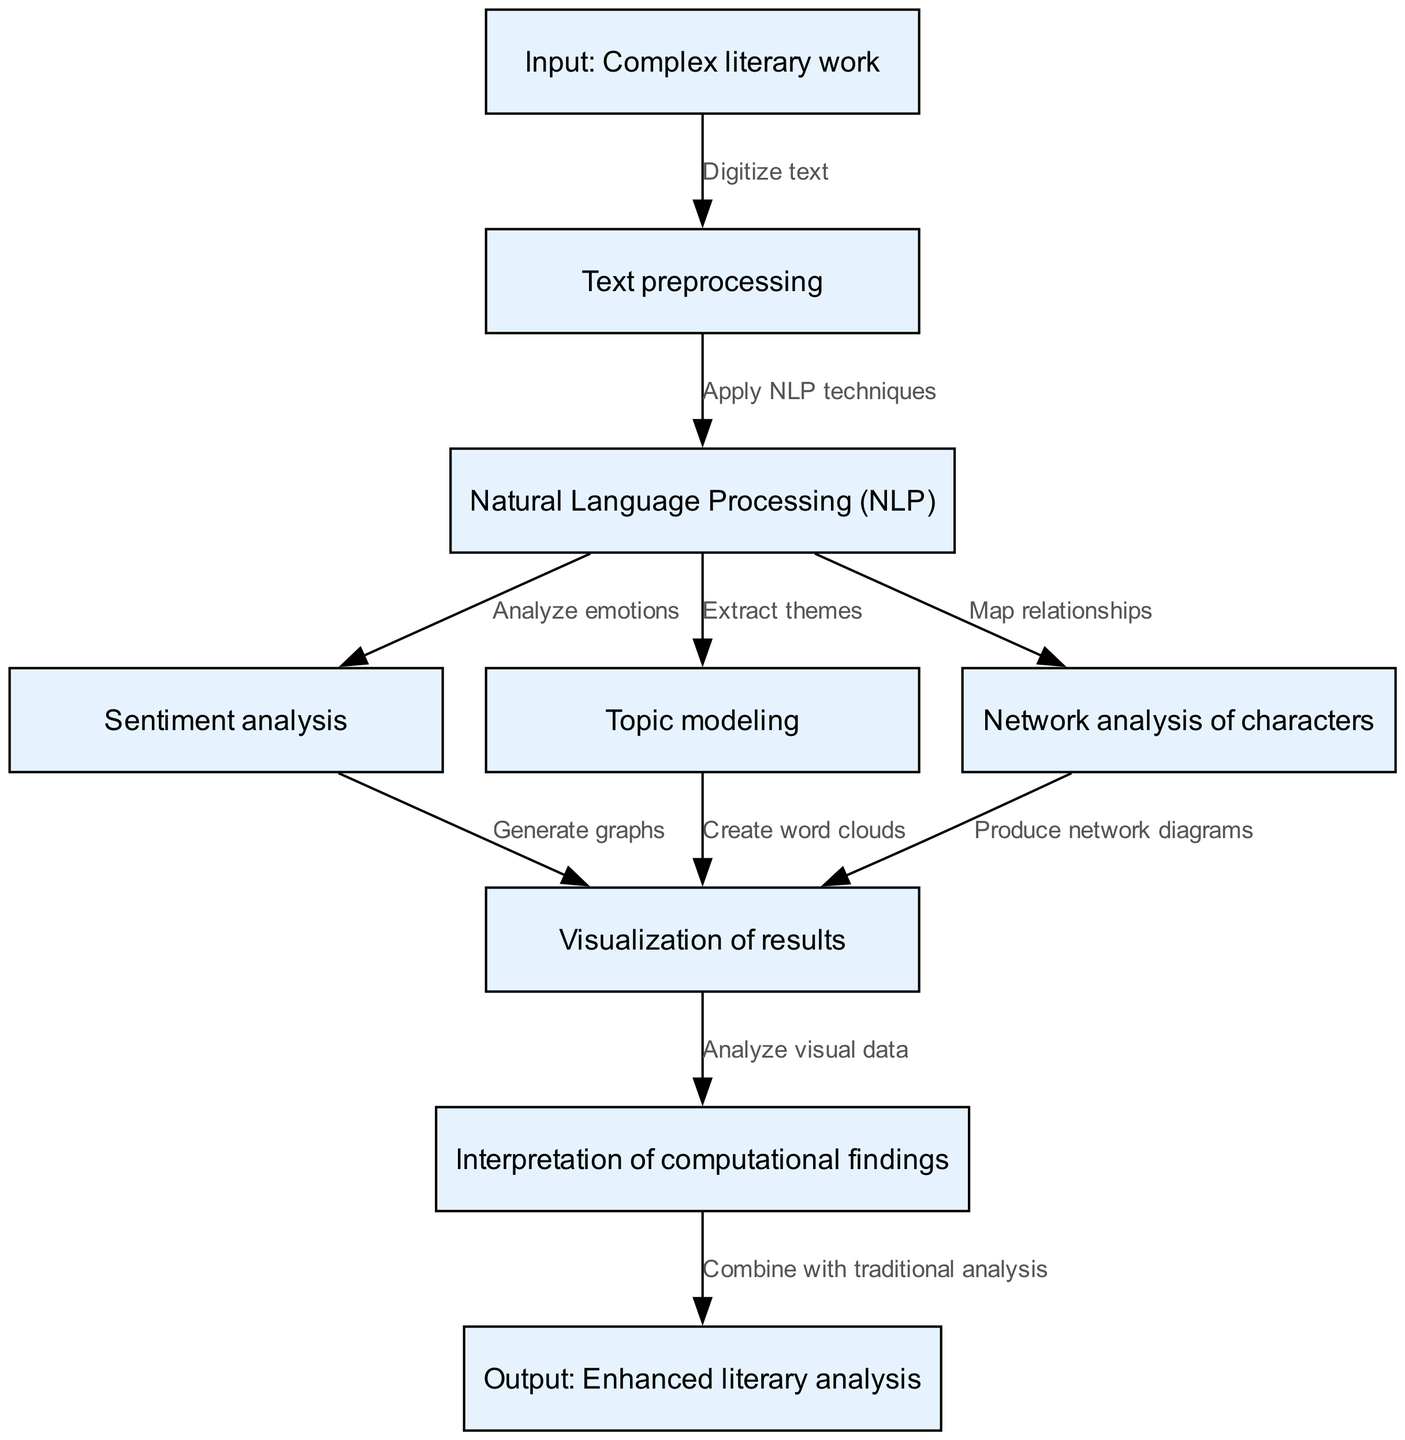What is the starting input for the analysis? The starting input node in the diagram is labeled "Input: Complex literary work," indicating that this is where the process begins.
Answer: Complex literary work How many nodes are present in the diagram? By counting all the items within the "nodes" array, there are a total of nine nodes depicted in the flow chart.
Answer: 9 What node follows "Text preprocessing"? Following the "Text preprocessing" node, the diagram indicates the next step is "Natural Language Processing (NLP)," which is the immediate consequence of preprocessing.
Answer: Natural Language Processing (NLP) Which analysis type focuses on emotions? The node dedicated to analyzing emotions is labeled "Sentiment analysis," signifying that this part of the process specifically addresses emotional content in the text.
Answer: Sentiment analysis What is produced from "Network analysis of characters"? The output related to "Network analysis of characters" leads to the node "Produce network diagrams," indicating that this is the result of analyzing character relationships.
Answer: Produce network diagrams How is "Visualization of results" achieved? The visualization of results is accomplished through three processes: "Generate graphs" from sentiment analysis, "Create word clouds" from topic modeling, and "Produce network diagrams" from character analysis, all combining to create visual outputs.
Answer: Generate graphs, Create word clouds, Produce network diagrams What final output is guaranteed after interpreting the computational findings? The flow chart specifies that after the "Interpretation of computational findings," the final output is "Output: Enhanced literary analysis," suggesting an improvement in literary analysis through the computational process.
Answer: Enhanced literary analysis Which node connects directly to both "Sentiment analysis" and "Topic modeling"? The "Natural Language Processing (NLP)" node serves as the connecting point, as both "Sentiment analysis" and "Topic modeling" stem from the processes described in NLP.
Answer: Natural Language Processing (NLP) What is the last step of the computational analysis process? The final step of the analysis process indicated in the flow chart is "Output: Enhanced literary analysis," marking the culmination of the preceding steps.
Answer: Output: Enhanced literary analysis 